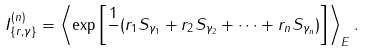<formula> <loc_0><loc_0><loc_500><loc_500>I _ { \{ r , \gamma \} } ^ { ( n ) } = \left \langle \exp \left [ \frac { 1 } { } ( r _ { 1 } S _ { \gamma _ { 1 } } + r _ { 2 } S _ { \gamma _ { 2 } } + \cdots + r _ { n } S _ { \gamma _ { n } } ) \right ] \right \rangle _ { E } .</formula> 